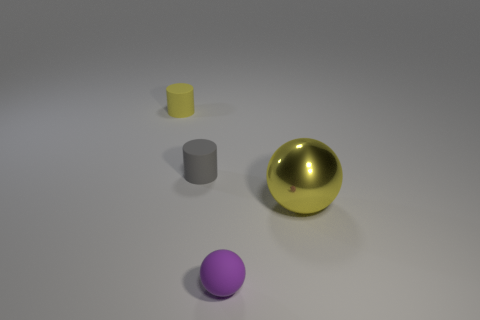Is there any other thing that is made of the same material as the large yellow object?
Your response must be concise. No. There is a yellow thing that is to the right of the yellow rubber object; is it the same size as the gray rubber cylinder?
Make the answer very short. No. Is there a tiny object that has the same color as the large thing?
Provide a succinct answer. Yes. What size is the purple object that is the same material as the gray object?
Provide a succinct answer. Small. Are there more small spheres right of the purple ball than spheres in front of the gray cylinder?
Your answer should be compact. No. How many other objects are the same material as the yellow ball?
Offer a very short reply. 0. Is the yellow thing that is behind the large yellow metallic ball made of the same material as the purple ball?
Your answer should be very brief. Yes. The gray rubber object has what shape?
Make the answer very short. Cylinder. Is the number of small rubber cylinders that are right of the purple rubber object greater than the number of yellow rubber things?
Offer a very short reply. No. Is there anything else that has the same shape as the large metallic thing?
Offer a very short reply. Yes. 